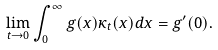<formula> <loc_0><loc_0><loc_500><loc_500>\lim _ { t \to 0 } \int _ { 0 } ^ { \infty } g ( x ) \kappa _ { t } ( x ) d x = g ^ { \prime } ( 0 ) .</formula> 